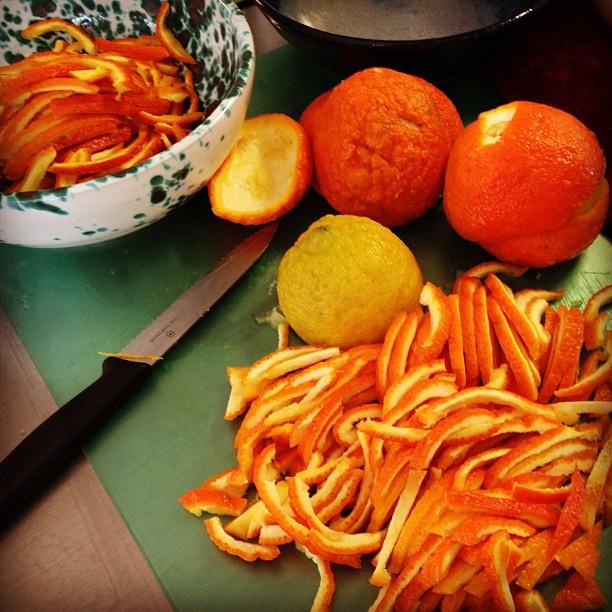Is the fruit in the foreground prickly?
Concise answer only. No. Have any oranges already been sliced?
Give a very brief answer. Yes. What utensil can be seen?
Short answer required. Knife. What type of utensil in by the food?
Concise answer only. Knife. How many different type of fruit is in this picture?
Concise answer only. 1. Which fruit is for sale?
Answer briefly. Orange. Are the fruits cut in pieces?
Concise answer only. Yes. What is in the bowl?
Be succinct. Orange peels. Can you see a banana?
Keep it brief. No. What eating utensil is visible?
Concise answer only. Knife. Is this orange?
Keep it brief. Yes. 